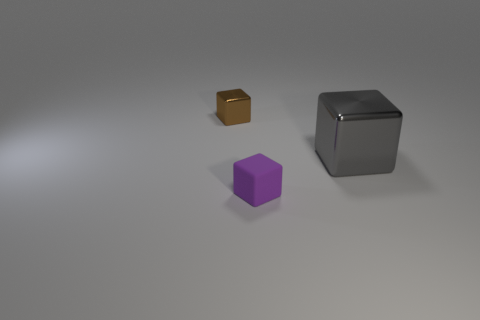Subtract all gray cubes. How many cubes are left? 2 Subtract all purple rubber cubes. How many cubes are left? 2 Add 1 purple things. How many objects exist? 4 Subtract all green cylinders. How many purple blocks are left? 1 Subtract 2 blocks. How many blocks are left? 1 Subtract all red cubes. Subtract all yellow balls. How many cubes are left? 3 Subtract all brown metal cubes. Subtract all purple matte things. How many objects are left? 1 Add 3 gray objects. How many gray objects are left? 4 Add 3 cubes. How many cubes exist? 6 Subtract 1 purple blocks. How many objects are left? 2 